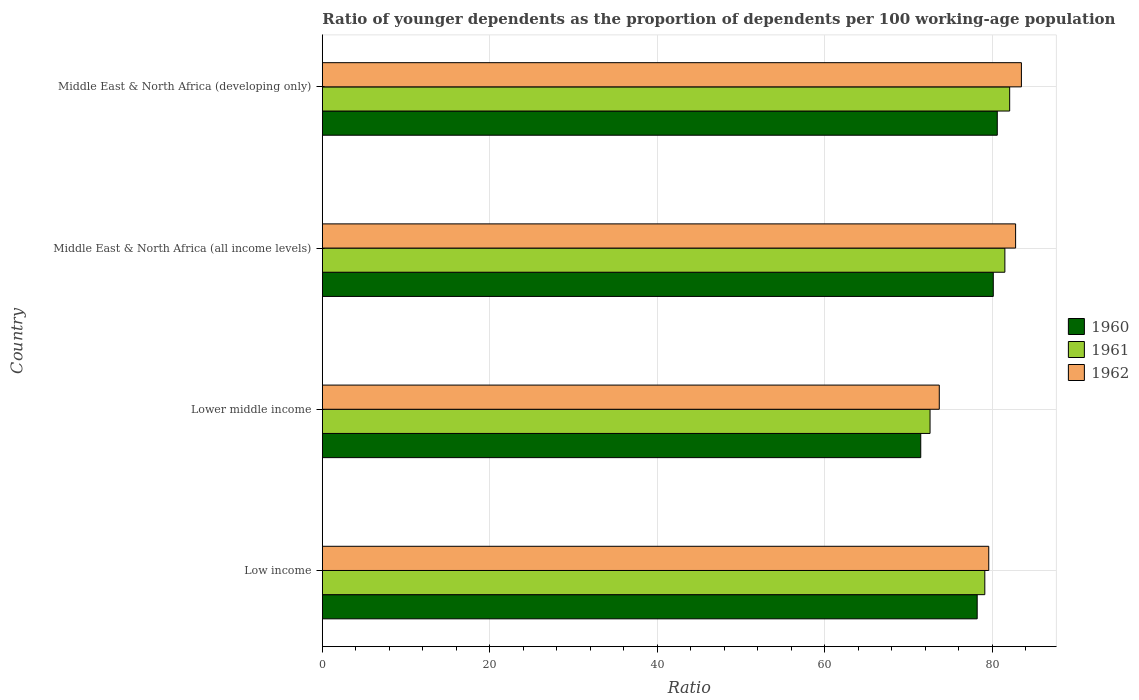How many groups of bars are there?
Provide a short and direct response. 4. How many bars are there on the 3rd tick from the top?
Make the answer very short. 3. What is the label of the 4th group of bars from the top?
Provide a succinct answer. Low income. In how many cases, is the number of bars for a given country not equal to the number of legend labels?
Provide a short and direct response. 0. What is the age dependency ratio(young) in 1960 in Middle East & North Africa (developing only)?
Ensure brevity in your answer.  80.59. Across all countries, what is the maximum age dependency ratio(young) in 1960?
Provide a succinct answer. 80.59. Across all countries, what is the minimum age dependency ratio(young) in 1960?
Offer a terse response. 71.45. In which country was the age dependency ratio(young) in 1960 maximum?
Provide a succinct answer. Middle East & North Africa (developing only). In which country was the age dependency ratio(young) in 1962 minimum?
Provide a succinct answer. Lower middle income. What is the total age dependency ratio(young) in 1962 in the graph?
Make the answer very short. 319.49. What is the difference between the age dependency ratio(young) in 1962 in Low income and that in Lower middle income?
Your answer should be very brief. 5.91. What is the difference between the age dependency ratio(young) in 1962 in Middle East & North Africa (developing only) and the age dependency ratio(young) in 1961 in Low income?
Give a very brief answer. 4.37. What is the average age dependency ratio(young) in 1960 per country?
Offer a terse response. 77.59. What is the difference between the age dependency ratio(young) in 1962 and age dependency ratio(young) in 1960 in Low income?
Ensure brevity in your answer.  1.38. In how many countries, is the age dependency ratio(young) in 1960 greater than 72 ?
Your response must be concise. 3. What is the ratio of the age dependency ratio(young) in 1961 in Low income to that in Middle East & North Africa (all income levels)?
Offer a terse response. 0.97. Is the difference between the age dependency ratio(young) in 1962 in Low income and Middle East & North Africa (developing only) greater than the difference between the age dependency ratio(young) in 1960 in Low income and Middle East & North Africa (developing only)?
Your answer should be very brief. No. What is the difference between the highest and the second highest age dependency ratio(young) in 1961?
Your answer should be compact. 0.57. What is the difference between the highest and the lowest age dependency ratio(young) in 1961?
Keep it short and to the point. 9.51. Is the sum of the age dependency ratio(young) in 1962 in Low income and Middle East & North Africa (all income levels) greater than the maximum age dependency ratio(young) in 1960 across all countries?
Offer a terse response. Yes. What does the 1st bar from the top in Lower middle income represents?
Your answer should be very brief. 1962. What does the 3rd bar from the bottom in Middle East & North Africa (developing only) represents?
Offer a terse response. 1962. How many countries are there in the graph?
Provide a succinct answer. 4. What is the difference between two consecutive major ticks on the X-axis?
Your response must be concise. 20. Are the values on the major ticks of X-axis written in scientific E-notation?
Provide a short and direct response. No. Does the graph contain grids?
Your answer should be compact. Yes. How are the legend labels stacked?
Offer a very short reply. Vertical. What is the title of the graph?
Keep it short and to the point. Ratio of younger dependents as the proportion of dependents per 100 working-age population. Does "1991" appear as one of the legend labels in the graph?
Your answer should be very brief. No. What is the label or title of the X-axis?
Keep it short and to the point. Ratio. What is the label or title of the Y-axis?
Offer a very short reply. Country. What is the Ratio of 1960 in Low income?
Make the answer very short. 78.19. What is the Ratio of 1961 in Low income?
Make the answer very short. 79.1. What is the Ratio in 1962 in Low income?
Offer a terse response. 79.57. What is the Ratio of 1960 in Lower middle income?
Your answer should be very brief. 71.45. What is the Ratio of 1961 in Lower middle income?
Provide a succinct answer. 72.56. What is the Ratio of 1962 in Lower middle income?
Provide a succinct answer. 73.67. What is the Ratio in 1960 in Middle East & North Africa (all income levels)?
Offer a terse response. 80.11. What is the Ratio in 1961 in Middle East & North Africa (all income levels)?
Your response must be concise. 81.5. What is the Ratio in 1962 in Middle East & North Africa (all income levels)?
Ensure brevity in your answer.  82.78. What is the Ratio in 1960 in Middle East & North Africa (developing only)?
Offer a very short reply. 80.59. What is the Ratio of 1961 in Middle East & North Africa (developing only)?
Offer a very short reply. 82.07. What is the Ratio in 1962 in Middle East & North Africa (developing only)?
Your answer should be very brief. 83.47. Across all countries, what is the maximum Ratio of 1960?
Provide a short and direct response. 80.59. Across all countries, what is the maximum Ratio in 1961?
Keep it short and to the point. 82.07. Across all countries, what is the maximum Ratio in 1962?
Your answer should be compact. 83.47. Across all countries, what is the minimum Ratio in 1960?
Your response must be concise. 71.45. Across all countries, what is the minimum Ratio of 1961?
Provide a short and direct response. 72.56. Across all countries, what is the minimum Ratio in 1962?
Ensure brevity in your answer.  73.67. What is the total Ratio of 1960 in the graph?
Give a very brief answer. 310.35. What is the total Ratio of 1961 in the graph?
Provide a short and direct response. 315.23. What is the total Ratio in 1962 in the graph?
Give a very brief answer. 319.49. What is the difference between the Ratio in 1960 in Low income and that in Lower middle income?
Keep it short and to the point. 6.74. What is the difference between the Ratio of 1961 in Low income and that in Lower middle income?
Offer a terse response. 6.54. What is the difference between the Ratio of 1962 in Low income and that in Lower middle income?
Keep it short and to the point. 5.91. What is the difference between the Ratio of 1960 in Low income and that in Middle East & North Africa (all income levels)?
Your answer should be very brief. -1.92. What is the difference between the Ratio in 1961 in Low income and that in Middle East & North Africa (all income levels)?
Offer a very short reply. -2.4. What is the difference between the Ratio of 1962 in Low income and that in Middle East & North Africa (all income levels)?
Provide a short and direct response. -3.21. What is the difference between the Ratio of 1960 in Low income and that in Middle East & North Africa (developing only)?
Your response must be concise. -2.4. What is the difference between the Ratio in 1961 in Low income and that in Middle East & North Africa (developing only)?
Give a very brief answer. -2.97. What is the difference between the Ratio in 1962 in Low income and that in Middle East & North Africa (developing only)?
Ensure brevity in your answer.  -3.9. What is the difference between the Ratio of 1960 in Lower middle income and that in Middle East & North Africa (all income levels)?
Provide a succinct answer. -8.66. What is the difference between the Ratio of 1961 in Lower middle income and that in Middle East & North Africa (all income levels)?
Offer a terse response. -8.94. What is the difference between the Ratio in 1962 in Lower middle income and that in Middle East & North Africa (all income levels)?
Offer a terse response. -9.11. What is the difference between the Ratio of 1960 in Lower middle income and that in Middle East & North Africa (developing only)?
Provide a short and direct response. -9.14. What is the difference between the Ratio in 1961 in Lower middle income and that in Middle East & North Africa (developing only)?
Provide a short and direct response. -9.51. What is the difference between the Ratio of 1962 in Lower middle income and that in Middle East & North Africa (developing only)?
Your answer should be very brief. -9.81. What is the difference between the Ratio in 1960 in Middle East & North Africa (all income levels) and that in Middle East & North Africa (developing only)?
Your answer should be compact. -0.48. What is the difference between the Ratio in 1961 in Middle East & North Africa (all income levels) and that in Middle East & North Africa (developing only)?
Your response must be concise. -0.57. What is the difference between the Ratio in 1962 in Middle East & North Africa (all income levels) and that in Middle East & North Africa (developing only)?
Ensure brevity in your answer.  -0.69. What is the difference between the Ratio in 1960 in Low income and the Ratio in 1961 in Lower middle income?
Your answer should be compact. 5.63. What is the difference between the Ratio of 1960 in Low income and the Ratio of 1962 in Lower middle income?
Provide a succinct answer. 4.53. What is the difference between the Ratio in 1961 in Low income and the Ratio in 1962 in Lower middle income?
Provide a succinct answer. 5.43. What is the difference between the Ratio of 1960 in Low income and the Ratio of 1961 in Middle East & North Africa (all income levels)?
Give a very brief answer. -3.31. What is the difference between the Ratio in 1960 in Low income and the Ratio in 1962 in Middle East & North Africa (all income levels)?
Ensure brevity in your answer.  -4.59. What is the difference between the Ratio of 1961 in Low income and the Ratio of 1962 in Middle East & North Africa (all income levels)?
Your answer should be very brief. -3.68. What is the difference between the Ratio of 1960 in Low income and the Ratio of 1961 in Middle East & North Africa (developing only)?
Your answer should be very brief. -3.88. What is the difference between the Ratio in 1960 in Low income and the Ratio in 1962 in Middle East & North Africa (developing only)?
Provide a succinct answer. -5.28. What is the difference between the Ratio of 1961 in Low income and the Ratio of 1962 in Middle East & North Africa (developing only)?
Provide a succinct answer. -4.37. What is the difference between the Ratio in 1960 in Lower middle income and the Ratio in 1961 in Middle East & North Africa (all income levels)?
Offer a terse response. -10.04. What is the difference between the Ratio of 1960 in Lower middle income and the Ratio of 1962 in Middle East & North Africa (all income levels)?
Your answer should be compact. -11.33. What is the difference between the Ratio in 1961 in Lower middle income and the Ratio in 1962 in Middle East & North Africa (all income levels)?
Your response must be concise. -10.22. What is the difference between the Ratio in 1960 in Lower middle income and the Ratio in 1961 in Middle East & North Africa (developing only)?
Offer a terse response. -10.62. What is the difference between the Ratio in 1960 in Lower middle income and the Ratio in 1962 in Middle East & North Africa (developing only)?
Your answer should be compact. -12.02. What is the difference between the Ratio in 1961 in Lower middle income and the Ratio in 1962 in Middle East & North Africa (developing only)?
Your answer should be very brief. -10.91. What is the difference between the Ratio in 1960 in Middle East & North Africa (all income levels) and the Ratio in 1961 in Middle East & North Africa (developing only)?
Your answer should be very brief. -1.96. What is the difference between the Ratio in 1960 in Middle East & North Africa (all income levels) and the Ratio in 1962 in Middle East & North Africa (developing only)?
Give a very brief answer. -3.36. What is the difference between the Ratio of 1961 in Middle East & North Africa (all income levels) and the Ratio of 1962 in Middle East & North Africa (developing only)?
Keep it short and to the point. -1.97. What is the average Ratio of 1960 per country?
Your answer should be compact. 77.59. What is the average Ratio in 1961 per country?
Provide a short and direct response. 78.81. What is the average Ratio of 1962 per country?
Offer a very short reply. 79.87. What is the difference between the Ratio in 1960 and Ratio in 1961 in Low income?
Your answer should be compact. -0.91. What is the difference between the Ratio in 1960 and Ratio in 1962 in Low income?
Offer a terse response. -1.38. What is the difference between the Ratio of 1961 and Ratio of 1962 in Low income?
Keep it short and to the point. -0.47. What is the difference between the Ratio in 1960 and Ratio in 1961 in Lower middle income?
Provide a succinct answer. -1.11. What is the difference between the Ratio in 1960 and Ratio in 1962 in Lower middle income?
Your answer should be compact. -2.21. What is the difference between the Ratio in 1961 and Ratio in 1962 in Lower middle income?
Provide a succinct answer. -1.1. What is the difference between the Ratio of 1960 and Ratio of 1961 in Middle East & North Africa (all income levels)?
Your answer should be very brief. -1.38. What is the difference between the Ratio in 1960 and Ratio in 1962 in Middle East & North Africa (all income levels)?
Ensure brevity in your answer.  -2.67. What is the difference between the Ratio of 1961 and Ratio of 1962 in Middle East & North Africa (all income levels)?
Make the answer very short. -1.28. What is the difference between the Ratio of 1960 and Ratio of 1961 in Middle East & North Africa (developing only)?
Offer a very short reply. -1.48. What is the difference between the Ratio of 1960 and Ratio of 1962 in Middle East & North Africa (developing only)?
Give a very brief answer. -2.88. What is the difference between the Ratio in 1961 and Ratio in 1962 in Middle East & North Africa (developing only)?
Keep it short and to the point. -1.4. What is the ratio of the Ratio of 1960 in Low income to that in Lower middle income?
Keep it short and to the point. 1.09. What is the ratio of the Ratio in 1961 in Low income to that in Lower middle income?
Offer a terse response. 1.09. What is the ratio of the Ratio of 1962 in Low income to that in Lower middle income?
Your answer should be very brief. 1.08. What is the ratio of the Ratio of 1960 in Low income to that in Middle East & North Africa (all income levels)?
Offer a terse response. 0.98. What is the ratio of the Ratio in 1961 in Low income to that in Middle East & North Africa (all income levels)?
Give a very brief answer. 0.97. What is the ratio of the Ratio in 1962 in Low income to that in Middle East & North Africa (all income levels)?
Provide a succinct answer. 0.96. What is the ratio of the Ratio of 1960 in Low income to that in Middle East & North Africa (developing only)?
Provide a succinct answer. 0.97. What is the ratio of the Ratio in 1961 in Low income to that in Middle East & North Africa (developing only)?
Your answer should be compact. 0.96. What is the ratio of the Ratio in 1962 in Low income to that in Middle East & North Africa (developing only)?
Provide a succinct answer. 0.95. What is the ratio of the Ratio in 1960 in Lower middle income to that in Middle East & North Africa (all income levels)?
Provide a short and direct response. 0.89. What is the ratio of the Ratio in 1961 in Lower middle income to that in Middle East & North Africa (all income levels)?
Your answer should be compact. 0.89. What is the ratio of the Ratio of 1962 in Lower middle income to that in Middle East & North Africa (all income levels)?
Your answer should be compact. 0.89. What is the ratio of the Ratio in 1960 in Lower middle income to that in Middle East & North Africa (developing only)?
Provide a short and direct response. 0.89. What is the ratio of the Ratio of 1961 in Lower middle income to that in Middle East & North Africa (developing only)?
Give a very brief answer. 0.88. What is the ratio of the Ratio in 1962 in Lower middle income to that in Middle East & North Africa (developing only)?
Your answer should be very brief. 0.88. What is the ratio of the Ratio in 1960 in Middle East & North Africa (all income levels) to that in Middle East & North Africa (developing only)?
Offer a very short reply. 0.99. What is the ratio of the Ratio of 1961 in Middle East & North Africa (all income levels) to that in Middle East & North Africa (developing only)?
Make the answer very short. 0.99. What is the ratio of the Ratio in 1962 in Middle East & North Africa (all income levels) to that in Middle East & North Africa (developing only)?
Your response must be concise. 0.99. What is the difference between the highest and the second highest Ratio of 1960?
Make the answer very short. 0.48. What is the difference between the highest and the second highest Ratio of 1961?
Offer a terse response. 0.57. What is the difference between the highest and the second highest Ratio in 1962?
Provide a succinct answer. 0.69. What is the difference between the highest and the lowest Ratio in 1960?
Your answer should be very brief. 9.14. What is the difference between the highest and the lowest Ratio in 1961?
Your response must be concise. 9.51. What is the difference between the highest and the lowest Ratio of 1962?
Your response must be concise. 9.81. 